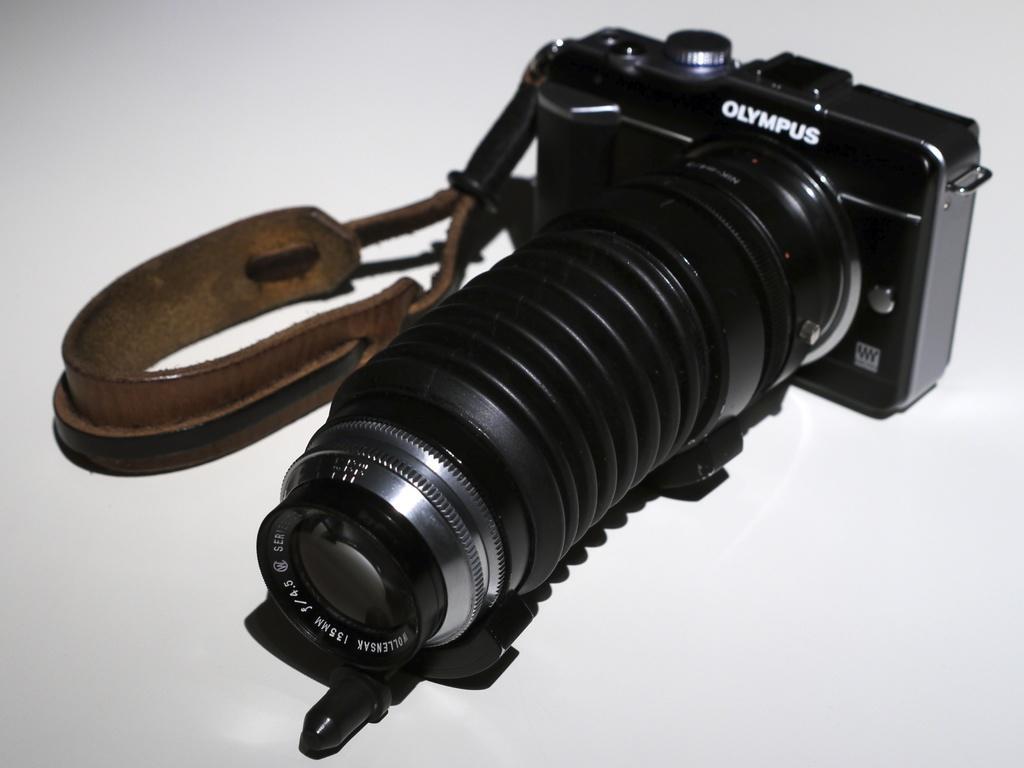Describe this image in one or two sentences. In this picture we can see a camera with belt on a white color platform. 